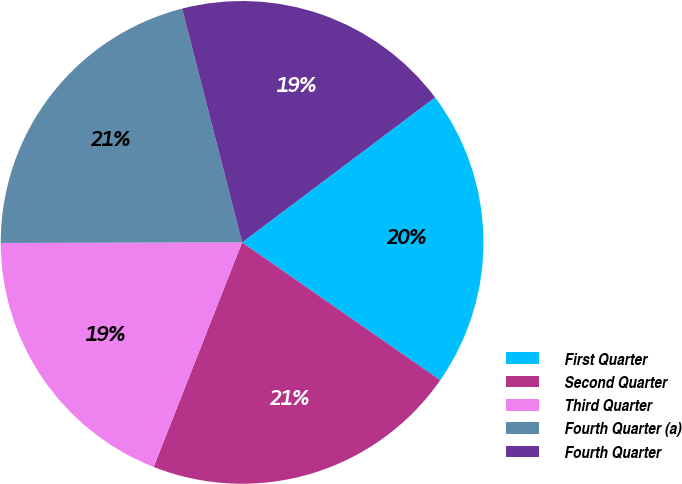<chart> <loc_0><loc_0><loc_500><loc_500><pie_chart><fcel>First Quarter<fcel>Second Quarter<fcel>Third Quarter<fcel>Fourth Quarter (a)<fcel>Fourth Quarter<nl><fcel>19.93%<fcel>21.3%<fcel>18.99%<fcel>21.04%<fcel>18.74%<nl></chart> 